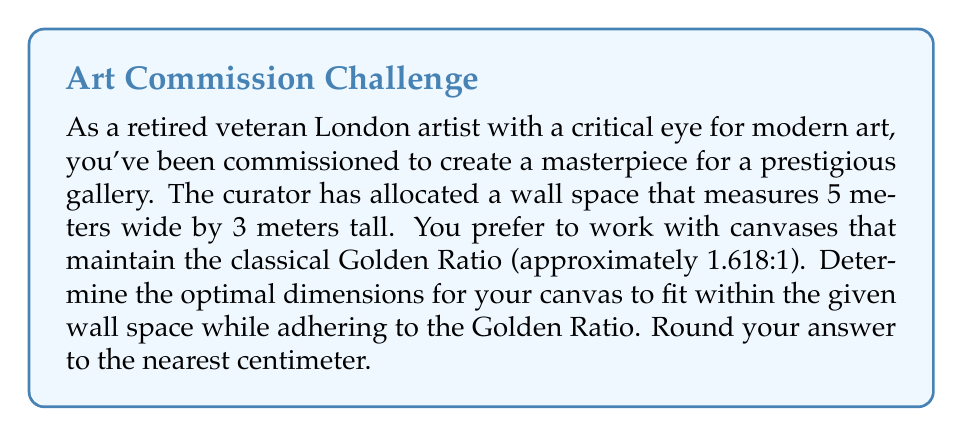What is the answer to this math problem? Let's approach this step-by-step:

1) The Golden Ratio is approximately 1.618:1. Let's denote the width of the canvas as $w$ and the height as $h$. We want:

   $$\frac{w}{h} = 1.618$$

2) We also know that the canvas must fit within the 5m x 3m wall space. This gives us two inequalities:

   $$w \leq 5$$
   $$h \leq 3$$

3) To maximize the canvas size while maintaining the Golden Ratio, we need to find the largest possible $w$ and $h$ that satisfy both the ratio and the inequalities.

4) We can express $h$ in terms of $w$ using the Golden Ratio:

   $$h = \frac{w}{1.618}$$

5) Now, we need to check which constraint will be hit first as we increase $w$:

   For width: $w = 5$
   For height: $\frac{w}{1.618} = 3$, which means $w = 3 \times 1.618 = 4.854$

6) The height constraint is hit first, so we'll use $w = 4.854$ meters.

7) Calculate the corresponding height:

   $$h = \frac{4.854}{1.618} = 3$$

8) Rounding to the nearest centimeter:

   $w = 485$ cm
   $h = 300$ cm
Answer: The optimal canvas dimensions are 485 cm wide by 300 cm tall. 